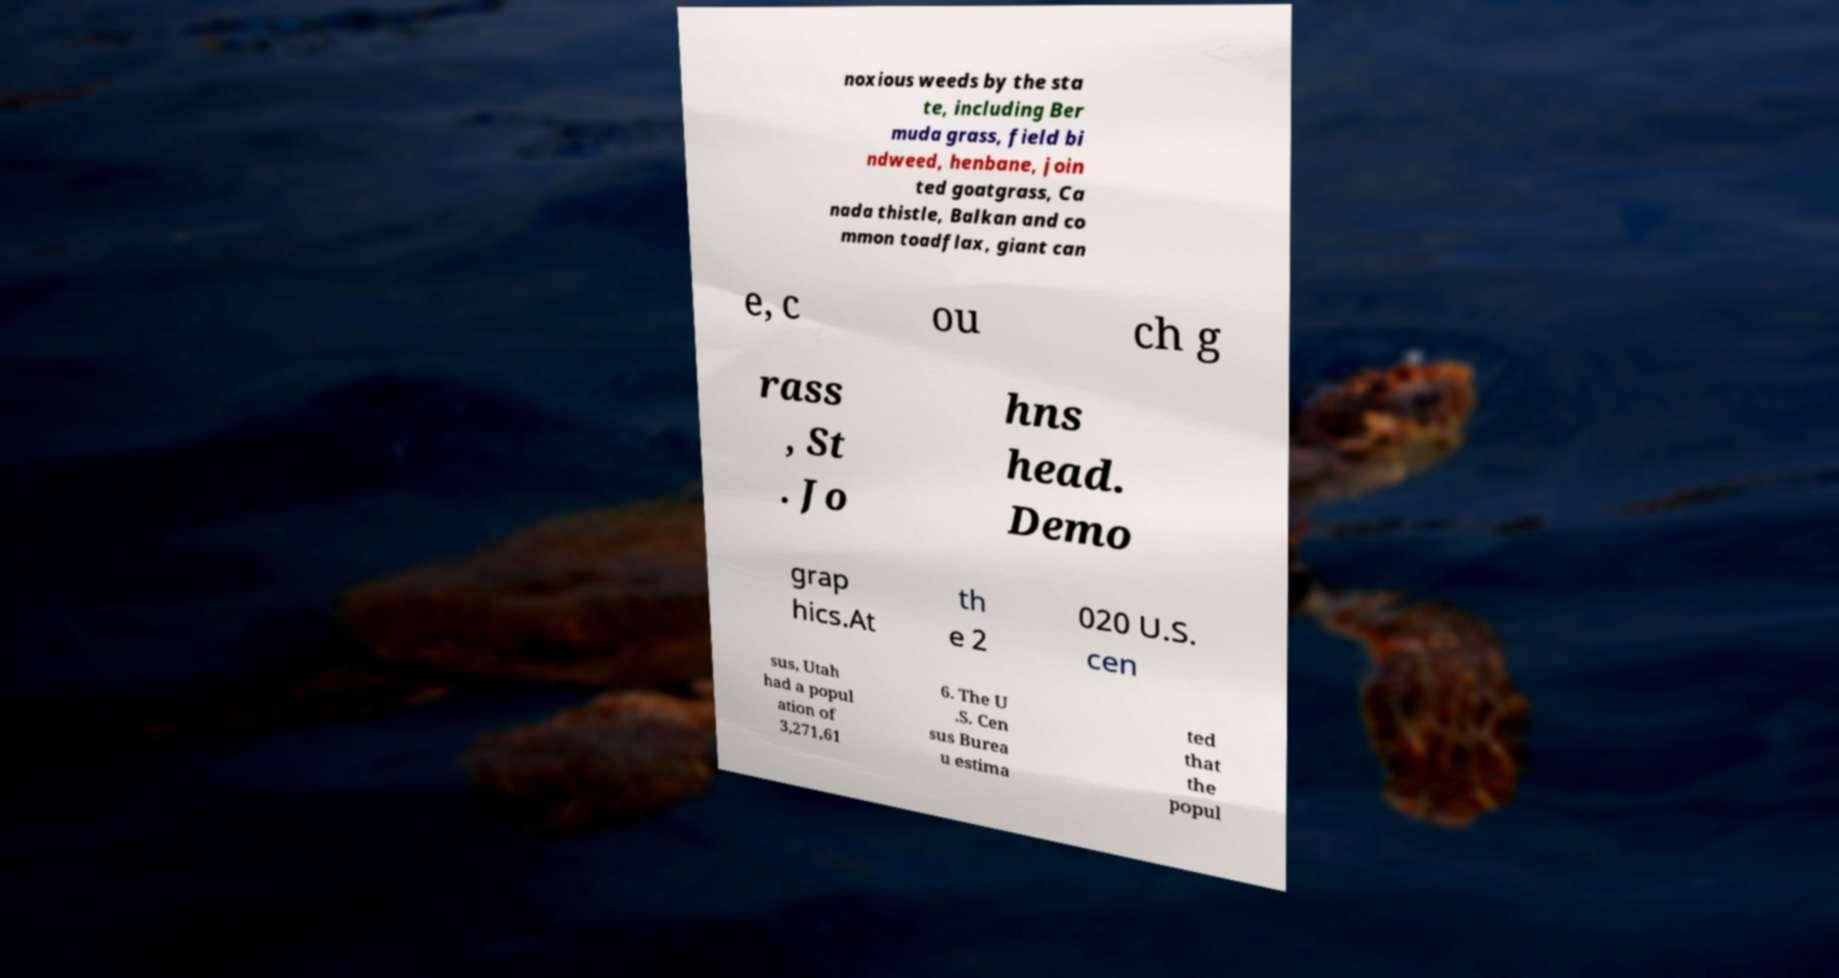Please read and relay the text visible in this image. What does it say? noxious weeds by the sta te, including Ber muda grass, field bi ndweed, henbane, join ted goatgrass, Ca nada thistle, Balkan and co mmon toadflax, giant can e, c ou ch g rass , St . Jo hns head. Demo grap hics.At th e 2 020 U.S. cen sus, Utah had a popul ation of 3,271,61 6. The U .S. Cen sus Burea u estima ted that the popul 